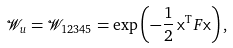Convert formula to latex. <formula><loc_0><loc_0><loc_500><loc_500>\mathcal { W } _ { u } = \mathcal { W } _ { 1 2 3 4 5 } = \exp \left ( - \frac { 1 } { 2 } \, \mathsf x ^ { \mathrm T } F \/ \mathsf x \right ) ,</formula> 